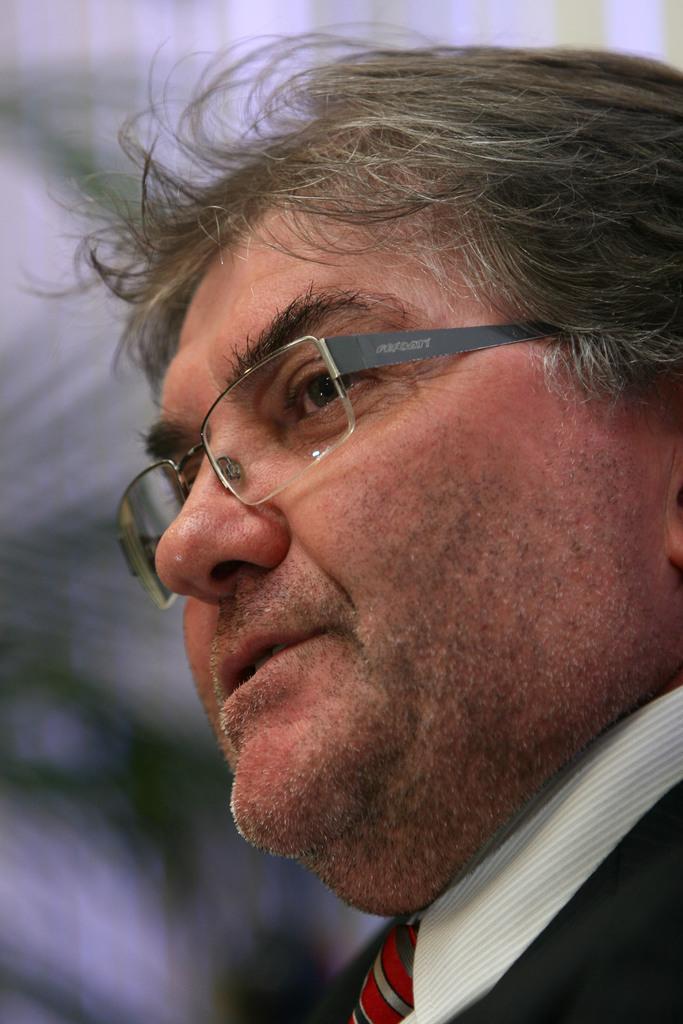How would you summarize this image in a sentence or two? In this image in front there is a person and the background of the image is blur. 